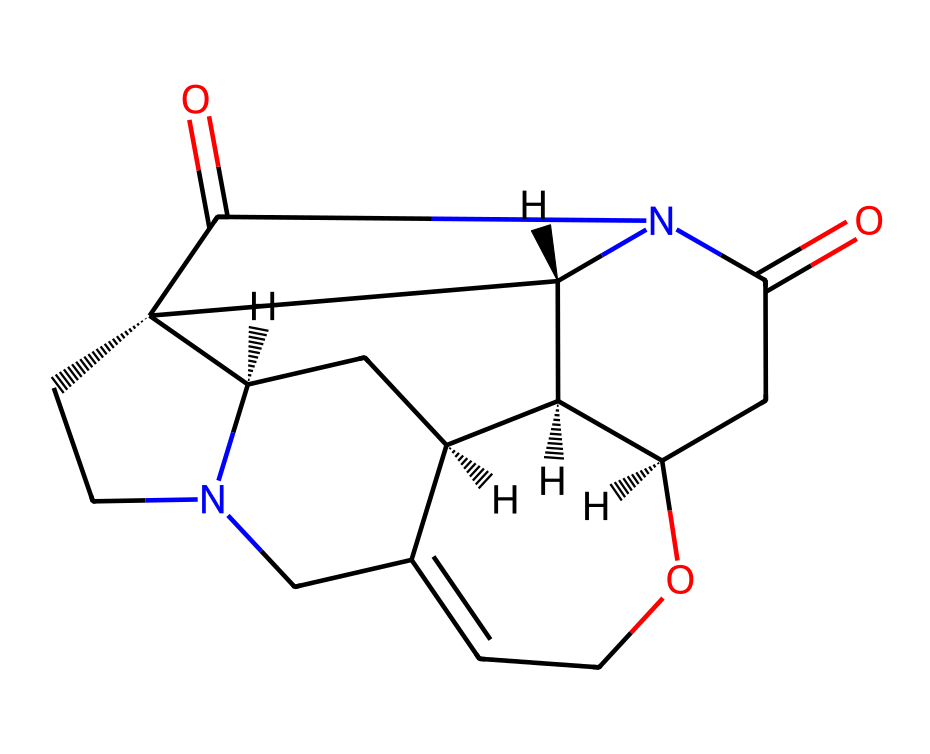how many chiral centers are in strychnine? To determine the number of chiral centers, we look at the SMILES representation and identify the carbons that have four different substituents. In the structure of strychnine, there are five such carbons.
Answer: five what is the molecular formula of strychnine? Analyzing the elements present in the SMILES representation, we count the number of each atom: carbon (C), hydrogen (H), oxygen (O), and nitrogen (N). The molecular formula for strychnine is C21H24N2O2.
Answer: C21H24N2O2 is strychnine an alkaloid? Strychnine is characterized by its nitrogen-containing ring structure, which is typical of alkaloids. Alkaloids are a class of compounds that include basic nitrogen atoms and are often derived from plants.
Answer: yes how many rings are in strychnine? By inspecting the structure in the SMILES, we can identify the cyclic parts of the molecule. Strychnine contains multiple interlinked ring systems. Counting the rings reveals that there are six.
Answer: six what is the total atom count in strychnine? To find the total atom count, we sum the different atoms in the molecular formula: 21 carbons, 24 hydrogens, 2 nitrogens, and 2 oxygens, which gives a total of 49 atoms for the molecule.
Answer: 49 how many nitrogen atoms are in strychnine? In the analysis of strychnine's structure from the SMILES representation, we see that there are two distinct nitrogen atoms present in the molecule.
Answer: two what type of bonding is present in strychnine? The SMILES representation reveals both covalent bonds due to the connectivity of atoms, as well as double bonds found between carbon and oxygen. This indicates that strychnine has primarily covalent bonding.
Answer: covalent 